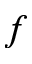Convert formula to latex. <formula><loc_0><loc_0><loc_500><loc_500>f</formula> 